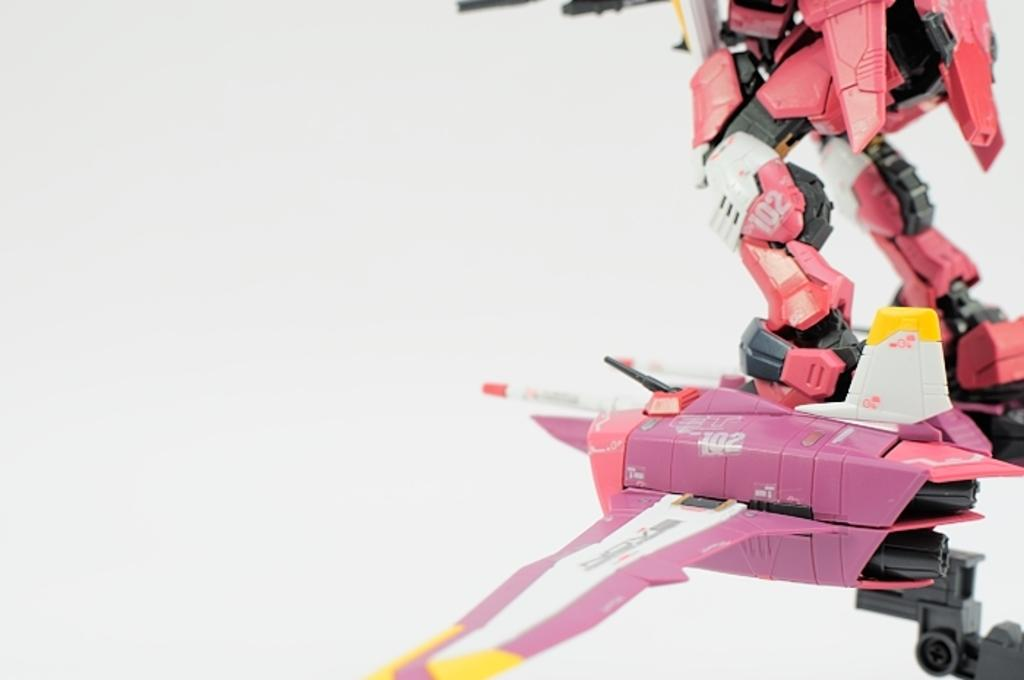What is the main subject in the image? There is a robot in the image. Where is the robot located in the image? The robot is on the right side of the image. What can be seen in the background of the image? There is a wall in the background of the image. What type of swing can be seen in the image? There is no swing present in the image; it features a robot on the right side with a wall in the background. 